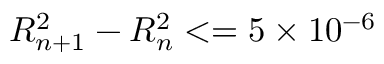<formula> <loc_0><loc_0><loc_500><loc_500>R _ { n + 1 } ^ { 2 } - R _ { n } ^ { 2 } < = 5 \times 1 0 ^ { - 6 }</formula> 